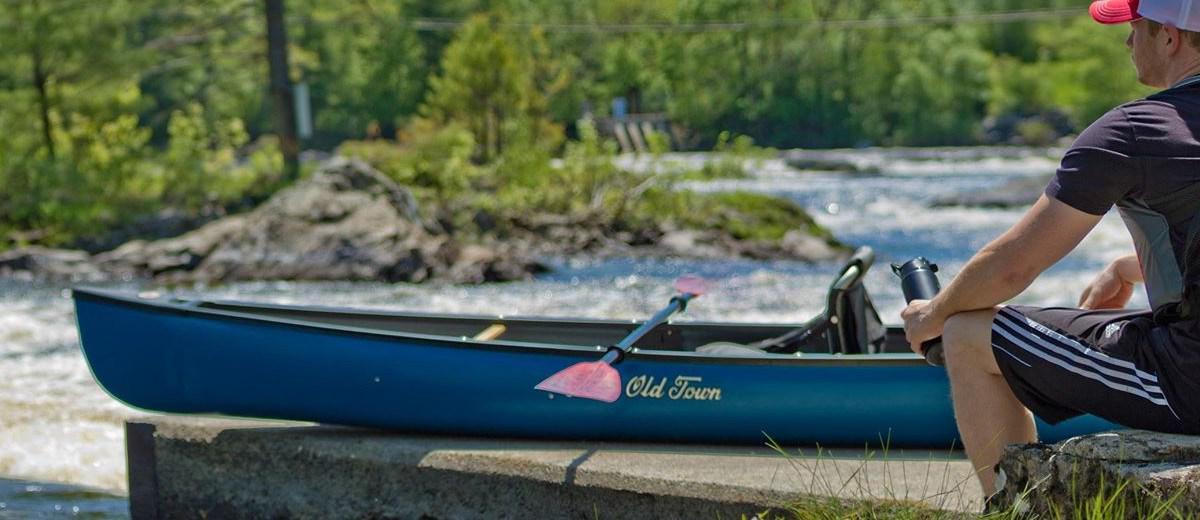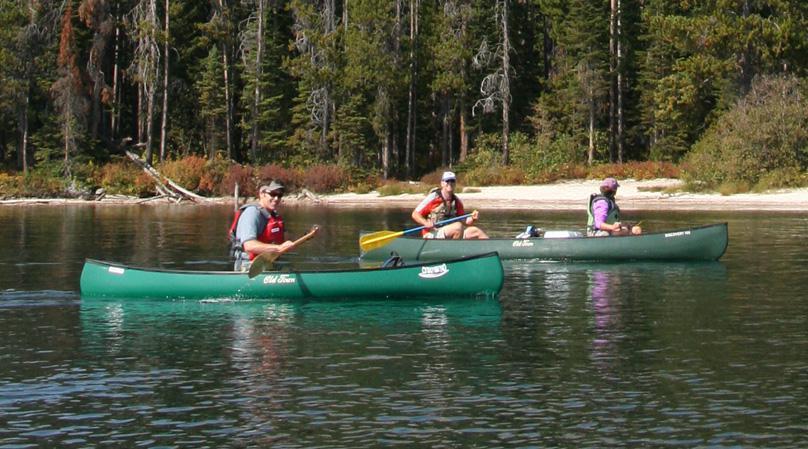The first image is the image on the left, the second image is the image on the right. Given the left and right images, does the statement "The left and right image contains the same number of boats." hold true? Answer yes or no. No. The first image is the image on the left, the second image is the image on the right. Considering the images on both sides, is "The left image features one light brown canoe with a white circle on its front, heading rightward with at least six people sitting in it." valid? Answer yes or no. No. 